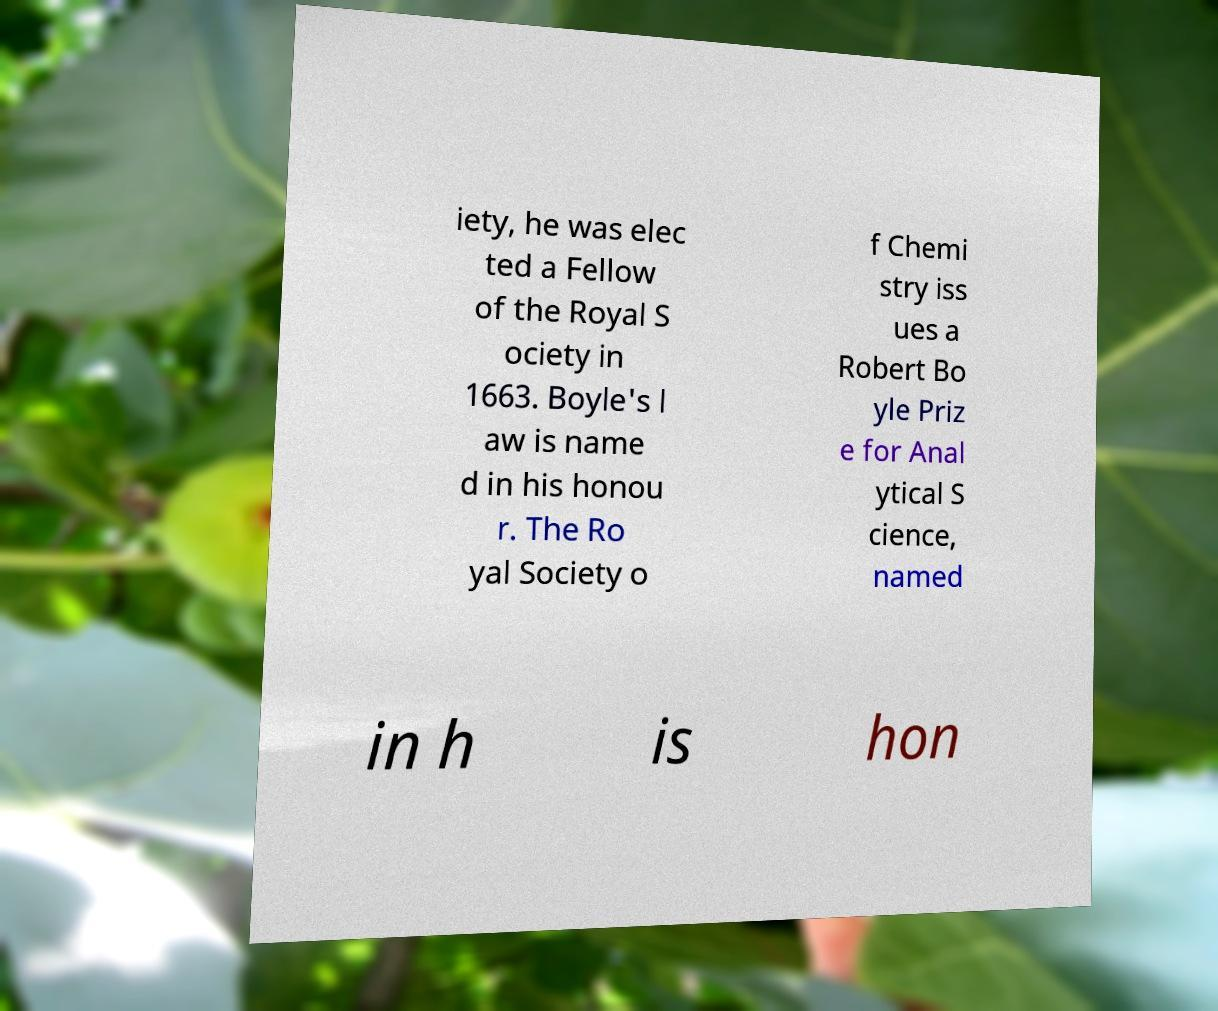There's text embedded in this image that I need extracted. Can you transcribe it verbatim? iety, he was elec ted a Fellow of the Royal S ociety in 1663. Boyle's l aw is name d in his honou r. The Ro yal Society o f Chemi stry iss ues a Robert Bo yle Priz e for Anal ytical S cience, named in h is hon 